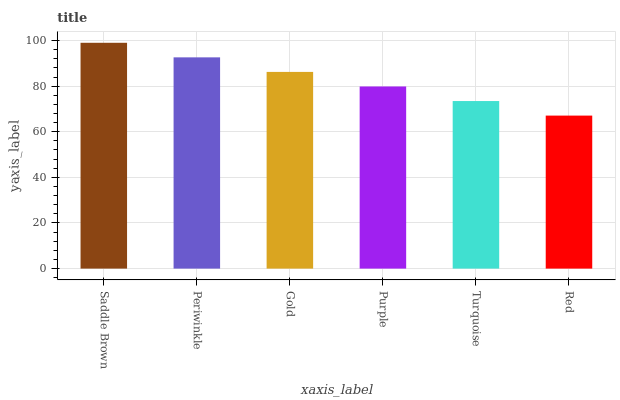Is Red the minimum?
Answer yes or no. Yes. Is Saddle Brown the maximum?
Answer yes or no. Yes. Is Periwinkle the minimum?
Answer yes or no. No. Is Periwinkle the maximum?
Answer yes or no. No. Is Saddle Brown greater than Periwinkle?
Answer yes or no. Yes. Is Periwinkle less than Saddle Brown?
Answer yes or no. Yes. Is Periwinkle greater than Saddle Brown?
Answer yes or no. No. Is Saddle Brown less than Periwinkle?
Answer yes or no. No. Is Gold the high median?
Answer yes or no. Yes. Is Purple the low median?
Answer yes or no. Yes. Is Turquoise the high median?
Answer yes or no. No. Is Turquoise the low median?
Answer yes or no. No. 